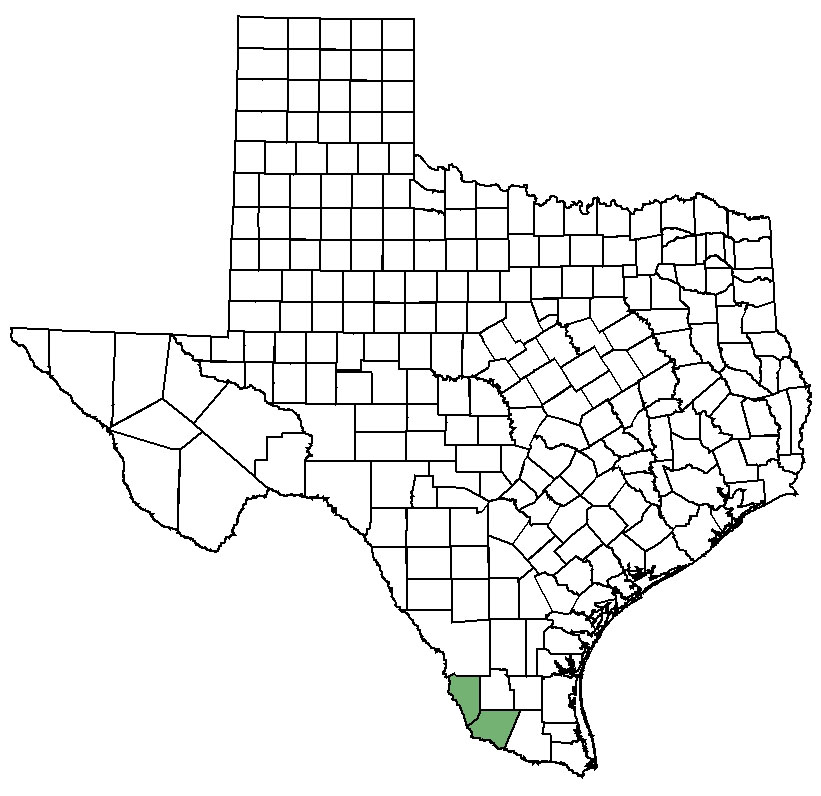Can you describe the unique geographical features of the highlighted county? The highlighted county exhibits a fascinating geographical landscape. Located in the southern part of Texas, it features a mix of flat plains and riparian zones, particularly influenced by the nearby Rio Grande. This river plays a crucial role in the county's agriculture and ecosystem. The area is known for its semi-arid climate, mesquite, and cactus flora, and wildlife including javelinas and various bird species. The terrain, climate, and water sources contribute to its distinctive environmental profile. How might the county's geography influence its economy? The geography of the highlighted county heavily influences its economy. The presence of the Rio Grande supports extensive agricultural activity, providing water resources for crops like melons, citrus fruits, and vegetables. The semi-arid climate is suitable for cattle ranching, an important economic activity in the region. Additionally, the unique natural landscape has fostered a growing ecotourism industry, appealing to visitors interested in the natural habitat and outdoor activities. The combination of agriculture, livestock, and tourism forms the economic backbone of the area. 